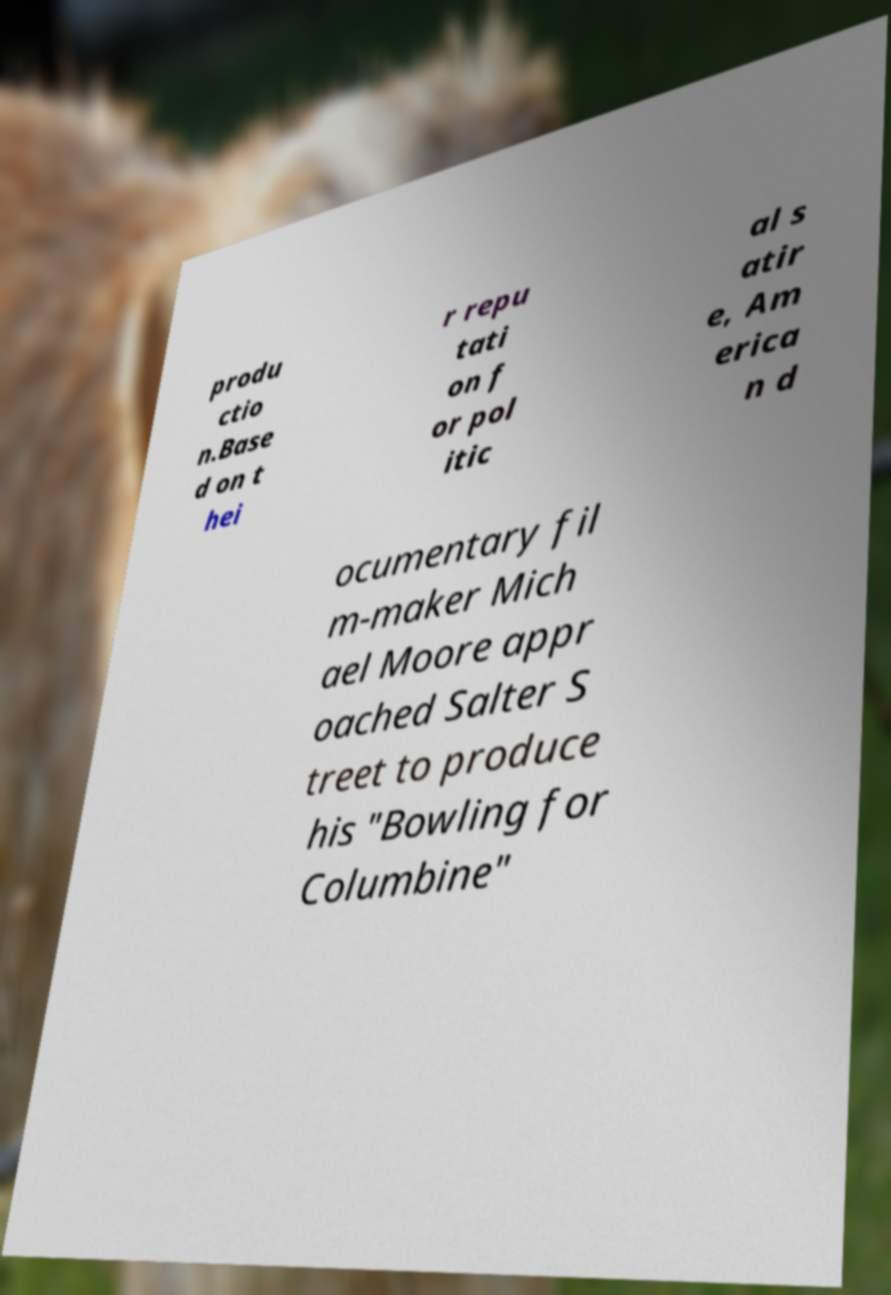Can you read and provide the text displayed in the image?This photo seems to have some interesting text. Can you extract and type it out for me? produ ctio n.Base d on t hei r repu tati on f or pol itic al s atir e, Am erica n d ocumentary fil m-maker Mich ael Moore appr oached Salter S treet to produce his "Bowling for Columbine" 